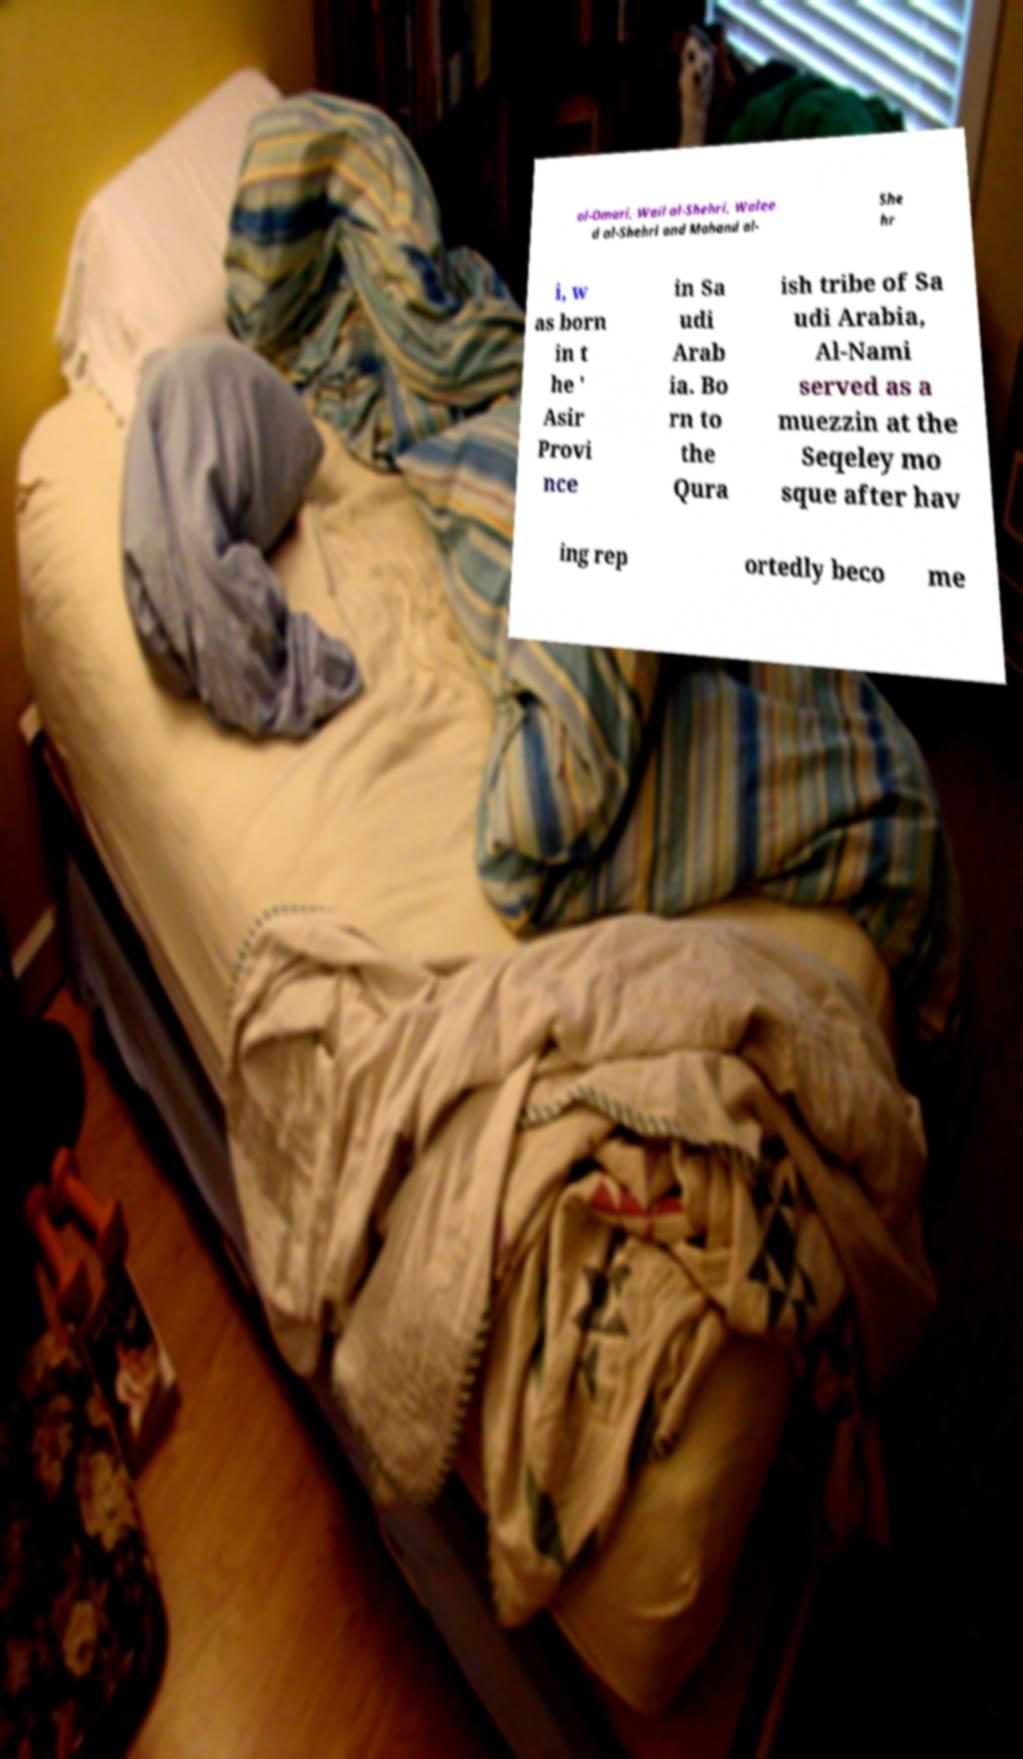There's text embedded in this image that I need extracted. Can you transcribe it verbatim? al-Omari, Wail al-Shehri, Walee d al-Shehri and Mohand al- She hr i, w as born in t he ' Asir Provi nce in Sa udi Arab ia. Bo rn to the Qura ish tribe of Sa udi Arabia, Al-Nami served as a muezzin at the Seqeley mo sque after hav ing rep ortedly beco me 